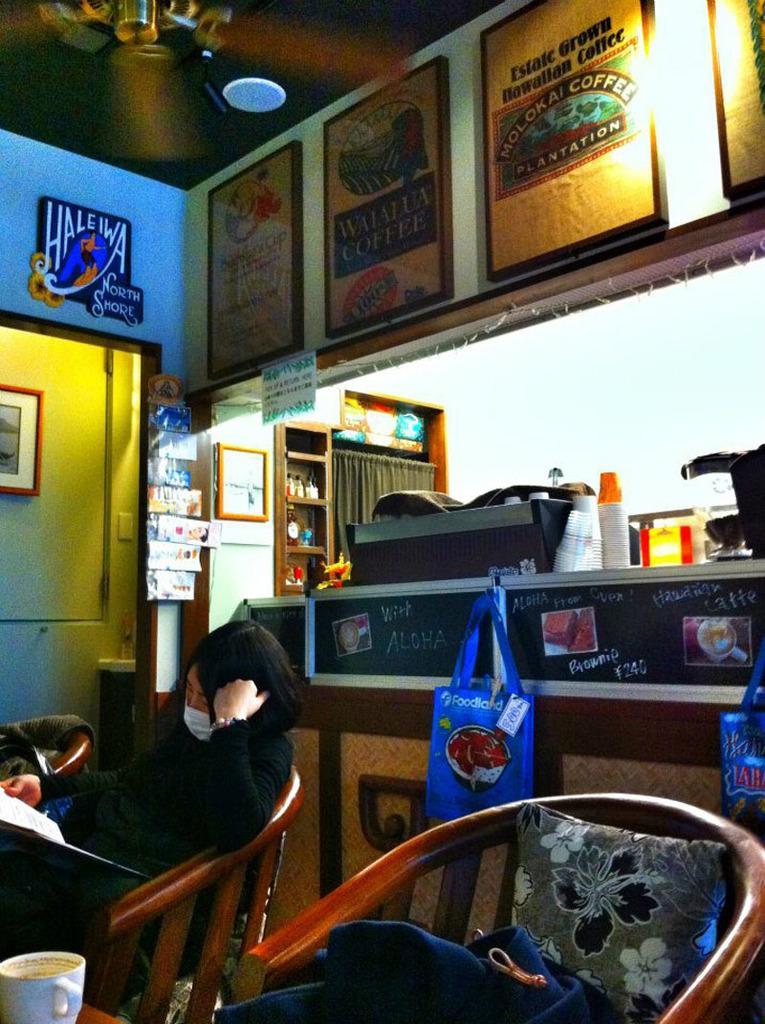Please provide a concise description of this image. In the picture I can see a person is sitting on a chair and holding something in the hand. I can also see another chair, a pillow, a cup, objects attached to the wall, bags, ceiling and some other things. 